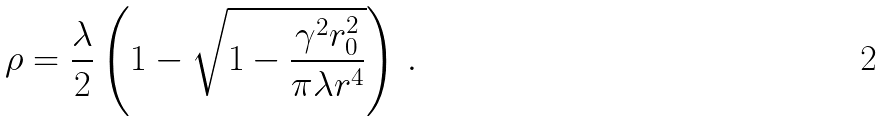<formula> <loc_0><loc_0><loc_500><loc_500>\rho = \frac { \lambda } { 2 } \left ( 1 - \sqrt { 1 - \frac { \gamma ^ { 2 } r _ { 0 } ^ { 2 } } { \pi \lambda r ^ { 4 } } } \right ) \, .</formula> 